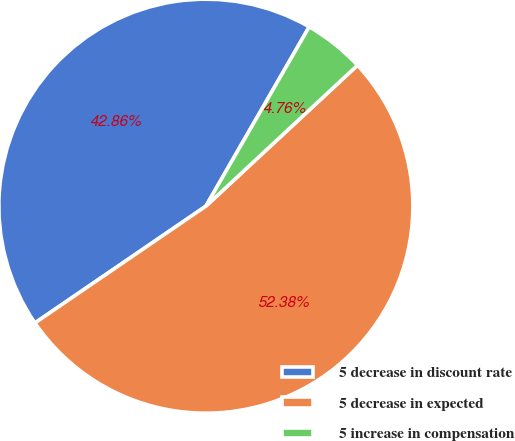Convert chart. <chart><loc_0><loc_0><loc_500><loc_500><pie_chart><fcel>5 decrease in discount rate<fcel>5 decrease in expected<fcel>5 increase in compensation<nl><fcel>42.86%<fcel>52.38%<fcel>4.76%<nl></chart> 